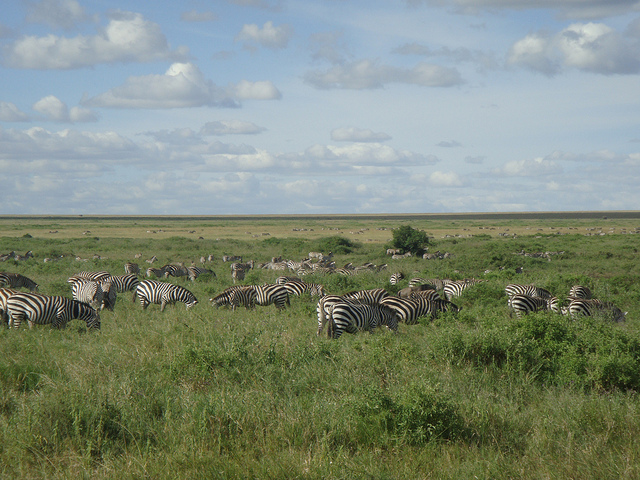<image>What country are the zebras in? I am not sure which country the zebras are in. It could be in Africa, Zimbabwe, or South Africa. What country are the zebras in? I don't know what country the zebras are in. It can be either Zimbabwe or Africa. 